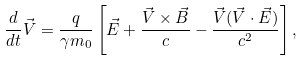<formula> <loc_0><loc_0><loc_500><loc_500>\frac { d } { d t } \vec { V } = \frac { q } { \gamma m _ { 0 } } \left [ \vec { E } + \frac { \vec { V } \times \vec { B } } { c } - \frac { \vec { V } ( \vec { V } \cdot \vec { E } ) } { c ^ { 2 } } \right ] ,</formula> 